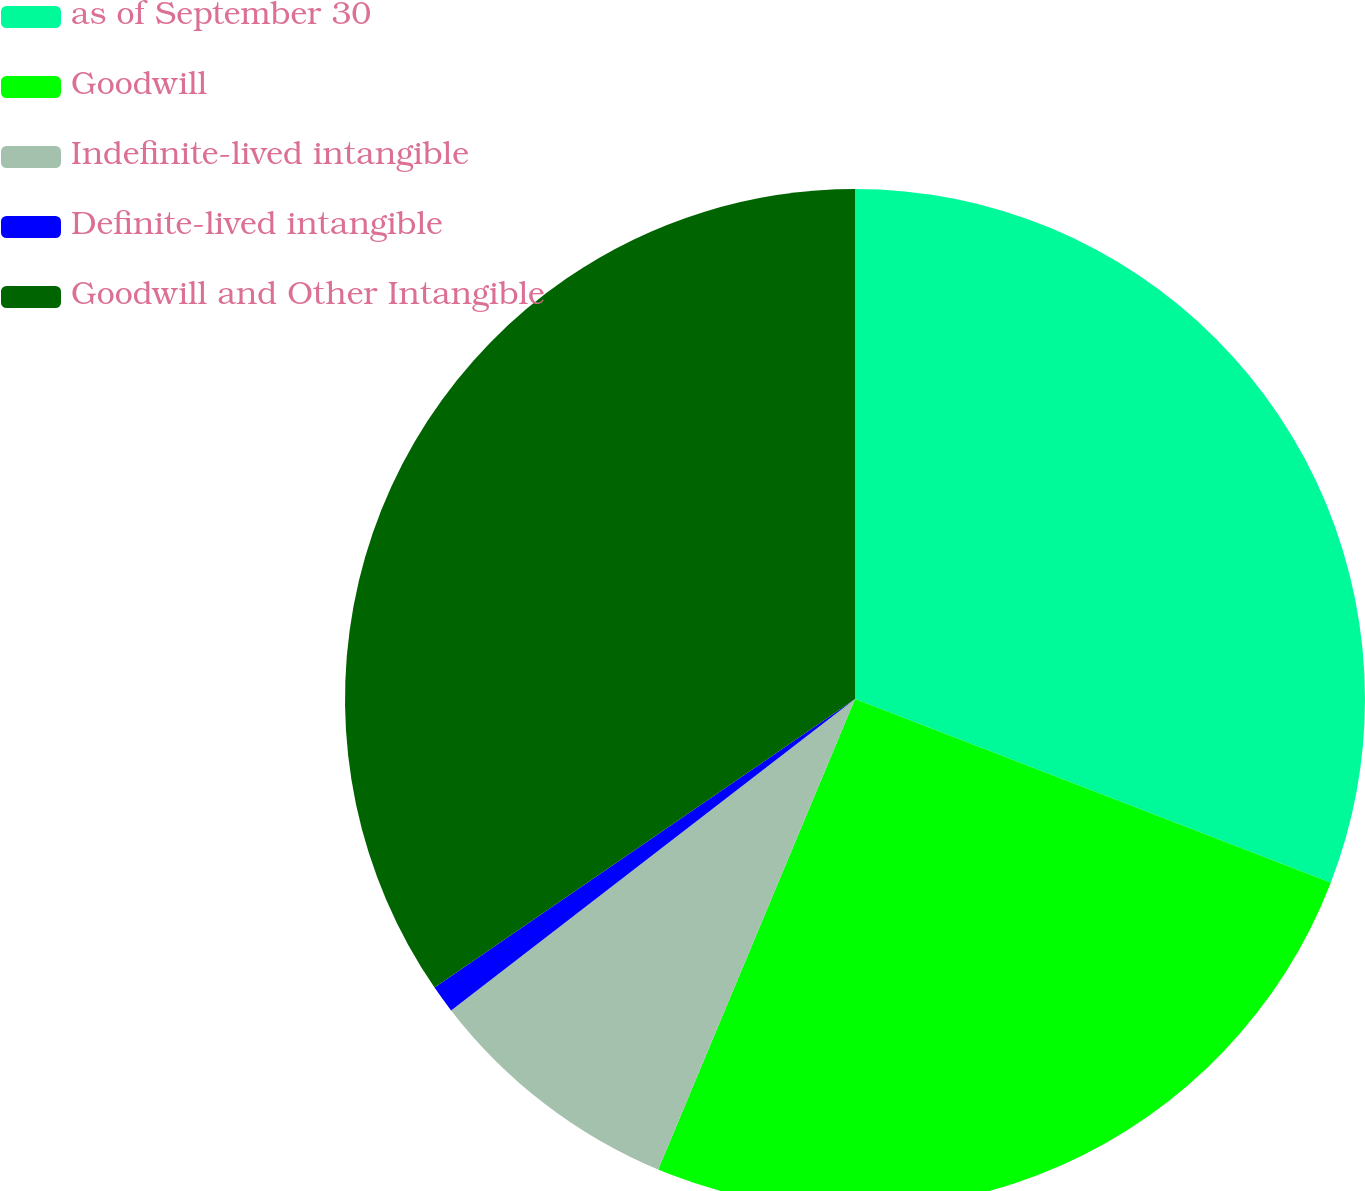Convert chart. <chart><loc_0><loc_0><loc_500><loc_500><pie_chart><fcel>as of September 30<fcel>Goodwill<fcel>Indefinite-lived intangible<fcel>Definite-lived intangible<fcel>Goodwill and Other Intangible<nl><fcel>30.86%<fcel>25.44%<fcel>8.24%<fcel>0.88%<fcel>34.57%<nl></chart> 